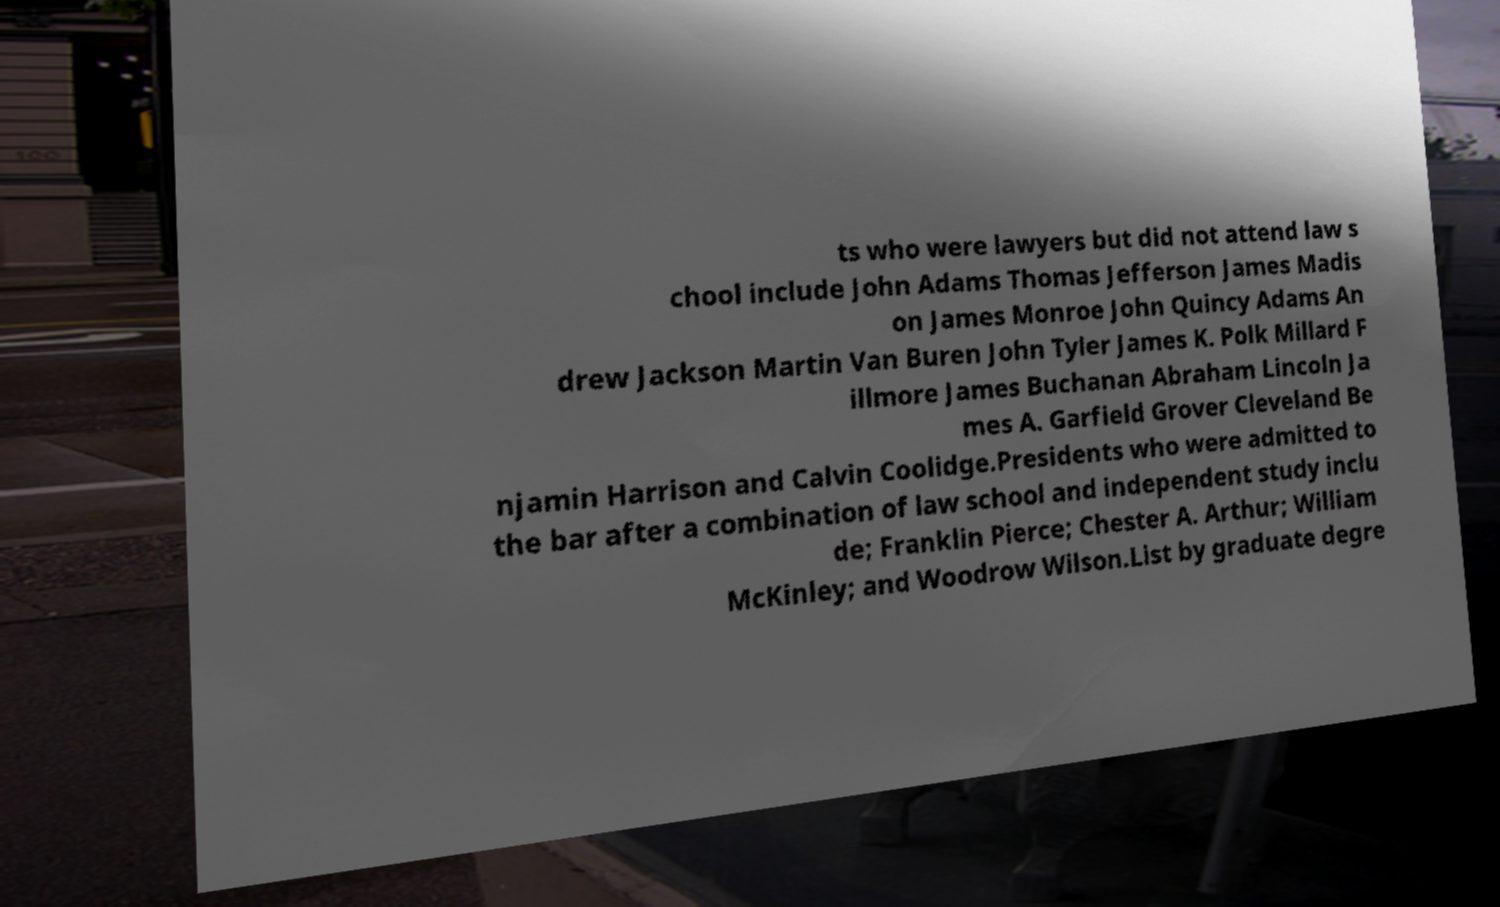There's text embedded in this image that I need extracted. Can you transcribe it verbatim? ts who were lawyers but did not attend law s chool include John Adams Thomas Jefferson James Madis on James Monroe John Quincy Adams An drew Jackson Martin Van Buren John Tyler James K. Polk Millard F illmore James Buchanan Abraham Lincoln Ja mes A. Garfield Grover Cleveland Be njamin Harrison and Calvin Coolidge.Presidents who were admitted to the bar after a combination of law school and independent study inclu de; Franklin Pierce; Chester A. Arthur; William McKinley; and Woodrow Wilson.List by graduate degre 